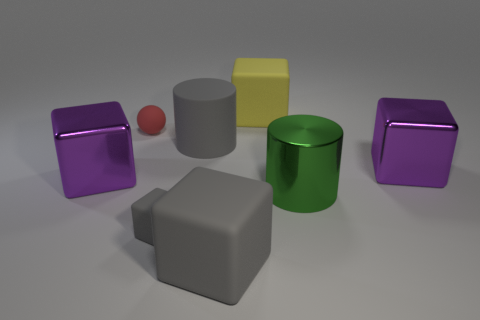What shape is the red matte thing?
Your answer should be compact. Sphere. What number of objects are balls or gray cubes?
Your response must be concise. 3. Do the tiny object that is behind the large green metal cylinder and the large shiny thing left of the tiny gray cube have the same color?
Provide a short and direct response. No. How many other objects are there of the same shape as the red object?
Offer a very short reply. 0. Is there a block?
Provide a succinct answer. Yes. What number of objects are metallic spheres or small things on the right side of the red thing?
Give a very brief answer. 1. There is a metal cube right of the yellow rubber thing; is it the same size as the big gray matte block?
Your answer should be compact. Yes. What number of other things are there of the same size as the red object?
Your answer should be compact. 1. The small ball has what color?
Your response must be concise. Red. There is a block that is on the right side of the yellow rubber cube; what is it made of?
Ensure brevity in your answer.  Metal. 